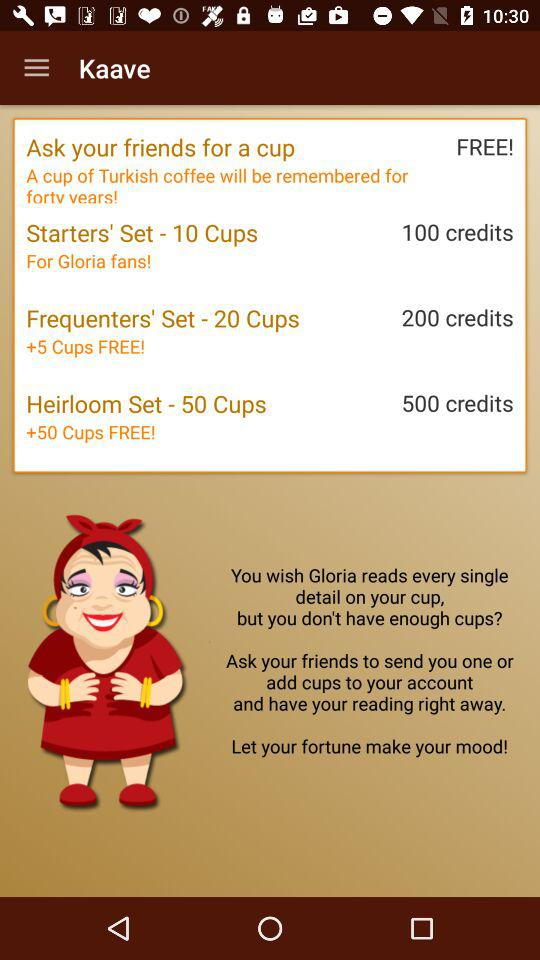How many more cups are included in the Heirloom Set than the Frequenters' Set?
Answer the question using a single word or phrase. 30 